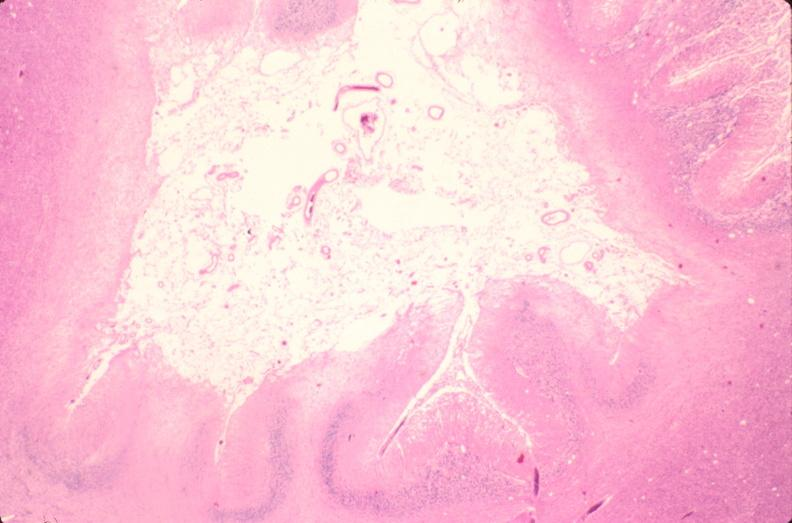does mucoepidermoid carcinoma show brain, old infarcts, embolic?
Answer the question using a single word or phrase. No 